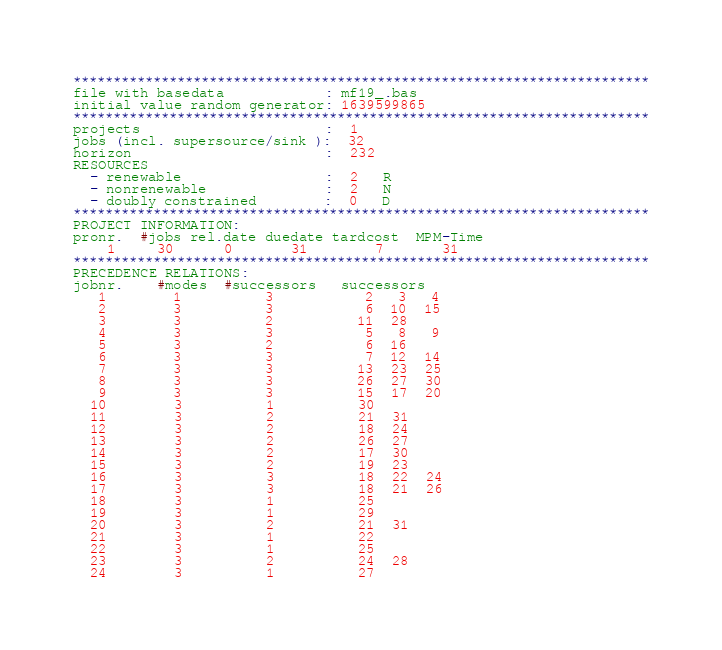Convert code to text. <code><loc_0><loc_0><loc_500><loc_500><_ObjectiveC_>************************************************************************
file with basedata            : mf19_.bas
initial value random generator: 1639599865
************************************************************************
projects                      :  1
jobs (incl. supersource/sink ):  32
horizon                       :  232
RESOURCES
  - renewable                 :  2   R
  - nonrenewable              :  2   N
  - doubly constrained        :  0   D
************************************************************************
PROJECT INFORMATION:
pronr.  #jobs rel.date duedate tardcost  MPM-Time
    1     30      0       31        7       31
************************************************************************
PRECEDENCE RELATIONS:
jobnr.    #modes  #successors   successors
   1        1          3           2   3   4
   2        3          3           6  10  15
   3        3          2          11  28
   4        3          3           5   8   9
   5        3          2           6  16
   6        3          3           7  12  14
   7        3          3          13  23  25
   8        3          3          26  27  30
   9        3          3          15  17  20
  10        3          1          30
  11        3          2          21  31
  12        3          2          18  24
  13        3          2          26  27
  14        3          2          17  30
  15        3          2          19  23
  16        3          3          18  22  24
  17        3          3          18  21  26
  18        3          1          25
  19        3          1          29
  20        3          2          21  31
  21        3          1          22
  22        3          1          25
  23        3          2          24  28
  24        3          1          27</code> 